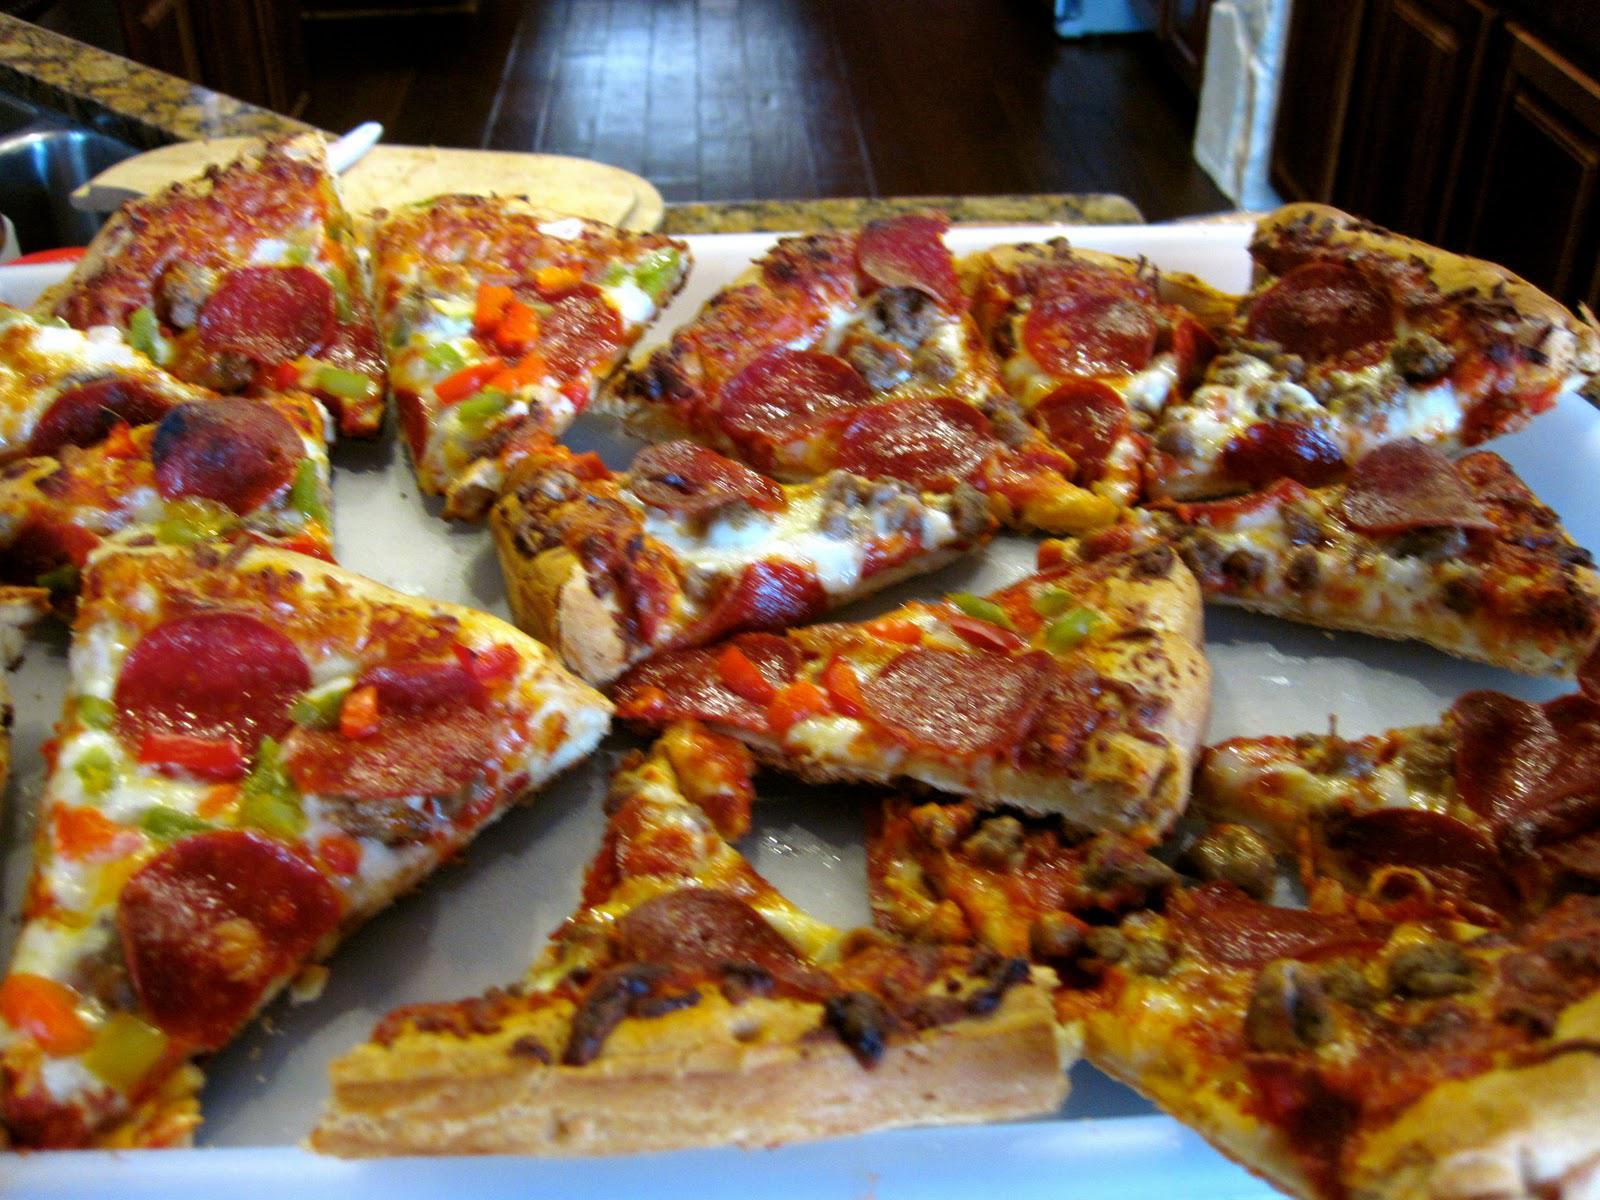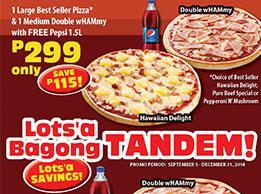The first image is the image on the left, the second image is the image on the right. For the images shown, is this caption "All pizzas in the right image are in boxes." true? Answer yes or no. No. 